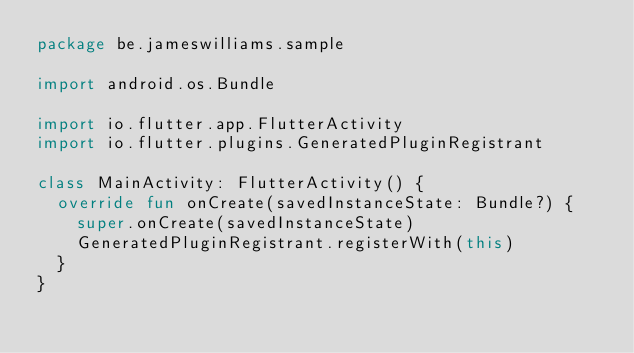<code> <loc_0><loc_0><loc_500><loc_500><_Kotlin_>package be.jameswilliams.sample

import android.os.Bundle

import io.flutter.app.FlutterActivity
import io.flutter.plugins.GeneratedPluginRegistrant

class MainActivity: FlutterActivity() {
  override fun onCreate(savedInstanceState: Bundle?) {
    super.onCreate(savedInstanceState)
    GeneratedPluginRegistrant.registerWith(this)
  }
}
</code> 